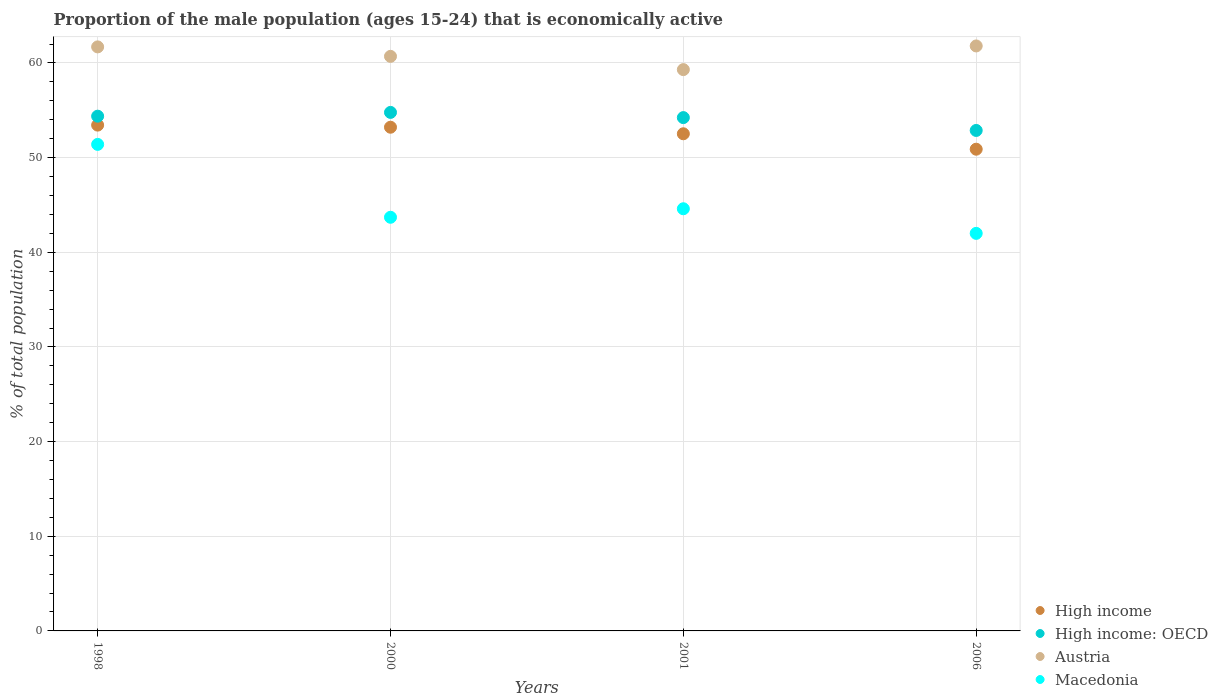Is the number of dotlines equal to the number of legend labels?
Offer a terse response. Yes. What is the proportion of the male population that is economically active in Macedonia in 2006?
Offer a terse response. 42. Across all years, what is the maximum proportion of the male population that is economically active in Austria?
Ensure brevity in your answer.  61.8. Across all years, what is the minimum proportion of the male population that is economically active in Austria?
Your response must be concise. 59.3. What is the total proportion of the male population that is economically active in High income in the graph?
Your answer should be very brief. 210.06. What is the difference between the proportion of the male population that is economically active in High income in 1998 and that in 2006?
Make the answer very short. 2.55. What is the difference between the proportion of the male population that is economically active in Austria in 2006 and the proportion of the male population that is economically active in Macedonia in 1998?
Ensure brevity in your answer.  10.4. What is the average proportion of the male population that is economically active in Macedonia per year?
Your answer should be compact. 45.43. In the year 1998, what is the difference between the proportion of the male population that is economically active in High income: OECD and proportion of the male population that is economically active in Austria?
Your answer should be compact. -7.32. In how many years, is the proportion of the male population that is economically active in High income greater than 38 %?
Offer a very short reply. 4. What is the ratio of the proportion of the male population that is economically active in High income in 1998 to that in 2006?
Your response must be concise. 1.05. Is the difference between the proportion of the male population that is economically active in High income: OECD in 2000 and 2006 greater than the difference between the proportion of the male population that is economically active in Austria in 2000 and 2006?
Keep it short and to the point. Yes. What is the difference between the highest and the second highest proportion of the male population that is economically active in High income?
Your answer should be compact. 0.22. What is the difference between the highest and the lowest proportion of the male population that is economically active in Austria?
Give a very brief answer. 2.5. Is it the case that in every year, the sum of the proportion of the male population that is economically active in Austria and proportion of the male population that is economically active in High income  is greater than the sum of proportion of the male population that is economically active in High income: OECD and proportion of the male population that is economically active in Macedonia?
Your response must be concise. No. Is the proportion of the male population that is economically active in Macedonia strictly greater than the proportion of the male population that is economically active in High income over the years?
Provide a succinct answer. No. How many years are there in the graph?
Offer a terse response. 4. What is the difference between two consecutive major ticks on the Y-axis?
Ensure brevity in your answer.  10. Are the values on the major ticks of Y-axis written in scientific E-notation?
Your response must be concise. No. Does the graph contain any zero values?
Offer a very short reply. No. Where does the legend appear in the graph?
Ensure brevity in your answer.  Bottom right. What is the title of the graph?
Make the answer very short. Proportion of the male population (ages 15-24) that is economically active. What is the label or title of the X-axis?
Make the answer very short. Years. What is the label or title of the Y-axis?
Your response must be concise. % of total population. What is the % of total population of High income in 1998?
Make the answer very short. 53.44. What is the % of total population of High income: OECD in 1998?
Offer a terse response. 54.38. What is the % of total population of Austria in 1998?
Offer a very short reply. 61.7. What is the % of total population of Macedonia in 1998?
Offer a very short reply. 51.4. What is the % of total population of High income in 2000?
Ensure brevity in your answer.  53.21. What is the % of total population of High income: OECD in 2000?
Ensure brevity in your answer.  54.78. What is the % of total population of Austria in 2000?
Provide a short and direct response. 60.7. What is the % of total population in Macedonia in 2000?
Provide a succinct answer. 43.7. What is the % of total population of High income in 2001?
Your response must be concise. 52.52. What is the % of total population in High income: OECD in 2001?
Your answer should be very brief. 54.23. What is the % of total population in Austria in 2001?
Your response must be concise. 59.3. What is the % of total population of Macedonia in 2001?
Provide a succinct answer. 44.6. What is the % of total population of High income in 2006?
Your answer should be compact. 50.89. What is the % of total population in High income: OECD in 2006?
Ensure brevity in your answer.  52.87. What is the % of total population in Austria in 2006?
Make the answer very short. 61.8. What is the % of total population in Macedonia in 2006?
Your answer should be very brief. 42. Across all years, what is the maximum % of total population of High income?
Your answer should be very brief. 53.44. Across all years, what is the maximum % of total population of High income: OECD?
Offer a very short reply. 54.78. Across all years, what is the maximum % of total population in Austria?
Your answer should be compact. 61.8. Across all years, what is the maximum % of total population of Macedonia?
Your answer should be very brief. 51.4. Across all years, what is the minimum % of total population in High income?
Offer a terse response. 50.89. Across all years, what is the minimum % of total population in High income: OECD?
Keep it short and to the point. 52.87. Across all years, what is the minimum % of total population in Austria?
Offer a terse response. 59.3. What is the total % of total population of High income in the graph?
Keep it short and to the point. 210.06. What is the total % of total population in High income: OECD in the graph?
Your answer should be very brief. 216.26. What is the total % of total population of Austria in the graph?
Keep it short and to the point. 243.5. What is the total % of total population in Macedonia in the graph?
Make the answer very short. 181.7. What is the difference between the % of total population in High income in 1998 and that in 2000?
Offer a very short reply. 0.22. What is the difference between the % of total population of High income: OECD in 1998 and that in 2000?
Ensure brevity in your answer.  -0.4. What is the difference between the % of total population in Macedonia in 1998 and that in 2000?
Provide a succinct answer. 7.7. What is the difference between the % of total population in High income in 1998 and that in 2001?
Keep it short and to the point. 0.92. What is the difference between the % of total population of High income: OECD in 1998 and that in 2001?
Keep it short and to the point. 0.15. What is the difference between the % of total population in Austria in 1998 and that in 2001?
Offer a very short reply. 2.4. What is the difference between the % of total population in High income in 1998 and that in 2006?
Your answer should be compact. 2.55. What is the difference between the % of total population of High income: OECD in 1998 and that in 2006?
Your answer should be compact. 1.51. What is the difference between the % of total population in Macedonia in 1998 and that in 2006?
Make the answer very short. 9.4. What is the difference between the % of total population in High income in 2000 and that in 2001?
Keep it short and to the point. 0.69. What is the difference between the % of total population of High income: OECD in 2000 and that in 2001?
Make the answer very short. 0.55. What is the difference between the % of total population of Macedonia in 2000 and that in 2001?
Provide a succinct answer. -0.9. What is the difference between the % of total population of High income in 2000 and that in 2006?
Ensure brevity in your answer.  2.32. What is the difference between the % of total population in High income: OECD in 2000 and that in 2006?
Your answer should be very brief. 1.91. What is the difference between the % of total population of Austria in 2000 and that in 2006?
Keep it short and to the point. -1.1. What is the difference between the % of total population in High income in 2001 and that in 2006?
Provide a short and direct response. 1.63. What is the difference between the % of total population in High income: OECD in 2001 and that in 2006?
Provide a short and direct response. 1.36. What is the difference between the % of total population in High income in 1998 and the % of total population in High income: OECD in 2000?
Give a very brief answer. -1.34. What is the difference between the % of total population in High income in 1998 and the % of total population in Austria in 2000?
Ensure brevity in your answer.  -7.26. What is the difference between the % of total population in High income in 1998 and the % of total population in Macedonia in 2000?
Your answer should be compact. 9.74. What is the difference between the % of total population in High income: OECD in 1998 and the % of total population in Austria in 2000?
Your answer should be compact. -6.32. What is the difference between the % of total population in High income: OECD in 1998 and the % of total population in Macedonia in 2000?
Your answer should be compact. 10.68. What is the difference between the % of total population in Austria in 1998 and the % of total population in Macedonia in 2000?
Make the answer very short. 18. What is the difference between the % of total population in High income in 1998 and the % of total population in High income: OECD in 2001?
Make the answer very short. -0.79. What is the difference between the % of total population in High income in 1998 and the % of total population in Austria in 2001?
Make the answer very short. -5.86. What is the difference between the % of total population in High income in 1998 and the % of total population in Macedonia in 2001?
Offer a very short reply. 8.84. What is the difference between the % of total population in High income: OECD in 1998 and the % of total population in Austria in 2001?
Provide a succinct answer. -4.92. What is the difference between the % of total population of High income: OECD in 1998 and the % of total population of Macedonia in 2001?
Offer a very short reply. 9.78. What is the difference between the % of total population of Austria in 1998 and the % of total population of Macedonia in 2001?
Your response must be concise. 17.1. What is the difference between the % of total population in High income in 1998 and the % of total population in High income: OECD in 2006?
Your answer should be compact. 0.56. What is the difference between the % of total population in High income in 1998 and the % of total population in Austria in 2006?
Make the answer very short. -8.36. What is the difference between the % of total population in High income in 1998 and the % of total population in Macedonia in 2006?
Offer a terse response. 11.44. What is the difference between the % of total population of High income: OECD in 1998 and the % of total population of Austria in 2006?
Keep it short and to the point. -7.42. What is the difference between the % of total population of High income: OECD in 1998 and the % of total population of Macedonia in 2006?
Provide a short and direct response. 12.38. What is the difference between the % of total population of High income in 2000 and the % of total population of High income: OECD in 2001?
Offer a very short reply. -1.02. What is the difference between the % of total population in High income in 2000 and the % of total population in Austria in 2001?
Your answer should be very brief. -6.09. What is the difference between the % of total population in High income in 2000 and the % of total population in Macedonia in 2001?
Provide a succinct answer. 8.61. What is the difference between the % of total population in High income: OECD in 2000 and the % of total population in Austria in 2001?
Give a very brief answer. -4.52. What is the difference between the % of total population in High income: OECD in 2000 and the % of total population in Macedonia in 2001?
Keep it short and to the point. 10.18. What is the difference between the % of total population in High income in 2000 and the % of total population in High income: OECD in 2006?
Ensure brevity in your answer.  0.34. What is the difference between the % of total population in High income in 2000 and the % of total population in Austria in 2006?
Your answer should be compact. -8.59. What is the difference between the % of total population in High income in 2000 and the % of total population in Macedonia in 2006?
Keep it short and to the point. 11.21. What is the difference between the % of total population of High income: OECD in 2000 and the % of total population of Austria in 2006?
Make the answer very short. -7.02. What is the difference between the % of total population of High income: OECD in 2000 and the % of total population of Macedonia in 2006?
Give a very brief answer. 12.78. What is the difference between the % of total population in Austria in 2000 and the % of total population in Macedonia in 2006?
Ensure brevity in your answer.  18.7. What is the difference between the % of total population in High income in 2001 and the % of total population in High income: OECD in 2006?
Provide a short and direct response. -0.35. What is the difference between the % of total population in High income in 2001 and the % of total population in Austria in 2006?
Keep it short and to the point. -9.28. What is the difference between the % of total population of High income in 2001 and the % of total population of Macedonia in 2006?
Ensure brevity in your answer.  10.52. What is the difference between the % of total population of High income: OECD in 2001 and the % of total population of Austria in 2006?
Your answer should be compact. -7.57. What is the difference between the % of total population in High income: OECD in 2001 and the % of total population in Macedonia in 2006?
Make the answer very short. 12.23. What is the difference between the % of total population in Austria in 2001 and the % of total population in Macedonia in 2006?
Offer a very short reply. 17.3. What is the average % of total population of High income per year?
Offer a very short reply. 52.52. What is the average % of total population in High income: OECD per year?
Offer a terse response. 54.07. What is the average % of total population in Austria per year?
Provide a succinct answer. 60.88. What is the average % of total population of Macedonia per year?
Provide a short and direct response. 45.42. In the year 1998, what is the difference between the % of total population in High income and % of total population in High income: OECD?
Your answer should be very brief. -0.94. In the year 1998, what is the difference between the % of total population in High income and % of total population in Austria?
Your answer should be compact. -8.26. In the year 1998, what is the difference between the % of total population of High income and % of total population of Macedonia?
Give a very brief answer. 2.04. In the year 1998, what is the difference between the % of total population in High income: OECD and % of total population in Austria?
Provide a short and direct response. -7.32. In the year 1998, what is the difference between the % of total population of High income: OECD and % of total population of Macedonia?
Your answer should be very brief. 2.98. In the year 1998, what is the difference between the % of total population of Austria and % of total population of Macedonia?
Offer a terse response. 10.3. In the year 2000, what is the difference between the % of total population in High income and % of total population in High income: OECD?
Your answer should be very brief. -1.57. In the year 2000, what is the difference between the % of total population of High income and % of total population of Austria?
Your answer should be compact. -7.49. In the year 2000, what is the difference between the % of total population of High income and % of total population of Macedonia?
Offer a terse response. 9.51. In the year 2000, what is the difference between the % of total population in High income: OECD and % of total population in Austria?
Your answer should be very brief. -5.92. In the year 2000, what is the difference between the % of total population in High income: OECD and % of total population in Macedonia?
Make the answer very short. 11.08. In the year 2000, what is the difference between the % of total population of Austria and % of total population of Macedonia?
Provide a short and direct response. 17. In the year 2001, what is the difference between the % of total population in High income and % of total population in High income: OECD?
Give a very brief answer. -1.71. In the year 2001, what is the difference between the % of total population in High income and % of total population in Austria?
Offer a terse response. -6.78. In the year 2001, what is the difference between the % of total population in High income and % of total population in Macedonia?
Your answer should be compact. 7.92. In the year 2001, what is the difference between the % of total population in High income: OECD and % of total population in Austria?
Keep it short and to the point. -5.07. In the year 2001, what is the difference between the % of total population of High income: OECD and % of total population of Macedonia?
Your answer should be very brief. 9.63. In the year 2001, what is the difference between the % of total population in Austria and % of total population in Macedonia?
Your response must be concise. 14.7. In the year 2006, what is the difference between the % of total population of High income and % of total population of High income: OECD?
Your answer should be compact. -1.98. In the year 2006, what is the difference between the % of total population in High income and % of total population in Austria?
Your response must be concise. -10.91. In the year 2006, what is the difference between the % of total population in High income and % of total population in Macedonia?
Your answer should be very brief. 8.89. In the year 2006, what is the difference between the % of total population of High income: OECD and % of total population of Austria?
Keep it short and to the point. -8.93. In the year 2006, what is the difference between the % of total population of High income: OECD and % of total population of Macedonia?
Make the answer very short. 10.87. In the year 2006, what is the difference between the % of total population in Austria and % of total population in Macedonia?
Provide a short and direct response. 19.8. What is the ratio of the % of total population in High income in 1998 to that in 2000?
Offer a terse response. 1. What is the ratio of the % of total population in High income: OECD in 1998 to that in 2000?
Provide a short and direct response. 0.99. What is the ratio of the % of total population of Austria in 1998 to that in 2000?
Provide a succinct answer. 1.02. What is the ratio of the % of total population in Macedonia in 1998 to that in 2000?
Your answer should be very brief. 1.18. What is the ratio of the % of total population of High income in 1998 to that in 2001?
Keep it short and to the point. 1.02. What is the ratio of the % of total population in Austria in 1998 to that in 2001?
Offer a very short reply. 1.04. What is the ratio of the % of total population in Macedonia in 1998 to that in 2001?
Ensure brevity in your answer.  1.15. What is the ratio of the % of total population in High income in 1998 to that in 2006?
Offer a terse response. 1.05. What is the ratio of the % of total population in High income: OECD in 1998 to that in 2006?
Your response must be concise. 1.03. What is the ratio of the % of total population in Austria in 1998 to that in 2006?
Provide a succinct answer. 1. What is the ratio of the % of total population of Macedonia in 1998 to that in 2006?
Make the answer very short. 1.22. What is the ratio of the % of total population of High income in 2000 to that in 2001?
Offer a terse response. 1.01. What is the ratio of the % of total population in Austria in 2000 to that in 2001?
Your response must be concise. 1.02. What is the ratio of the % of total population in Macedonia in 2000 to that in 2001?
Offer a terse response. 0.98. What is the ratio of the % of total population in High income in 2000 to that in 2006?
Your answer should be very brief. 1.05. What is the ratio of the % of total population in High income: OECD in 2000 to that in 2006?
Keep it short and to the point. 1.04. What is the ratio of the % of total population in Austria in 2000 to that in 2006?
Make the answer very short. 0.98. What is the ratio of the % of total population in Macedonia in 2000 to that in 2006?
Ensure brevity in your answer.  1.04. What is the ratio of the % of total population in High income in 2001 to that in 2006?
Your answer should be compact. 1.03. What is the ratio of the % of total population in High income: OECD in 2001 to that in 2006?
Make the answer very short. 1.03. What is the ratio of the % of total population of Austria in 2001 to that in 2006?
Your answer should be compact. 0.96. What is the ratio of the % of total population of Macedonia in 2001 to that in 2006?
Give a very brief answer. 1.06. What is the difference between the highest and the second highest % of total population in High income?
Your answer should be compact. 0.22. What is the difference between the highest and the second highest % of total population of High income: OECD?
Make the answer very short. 0.4. What is the difference between the highest and the second highest % of total population of Austria?
Give a very brief answer. 0.1. What is the difference between the highest and the second highest % of total population of Macedonia?
Provide a succinct answer. 6.8. What is the difference between the highest and the lowest % of total population in High income?
Offer a very short reply. 2.55. What is the difference between the highest and the lowest % of total population of High income: OECD?
Your answer should be very brief. 1.91. What is the difference between the highest and the lowest % of total population of Austria?
Give a very brief answer. 2.5. What is the difference between the highest and the lowest % of total population in Macedonia?
Provide a short and direct response. 9.4. 